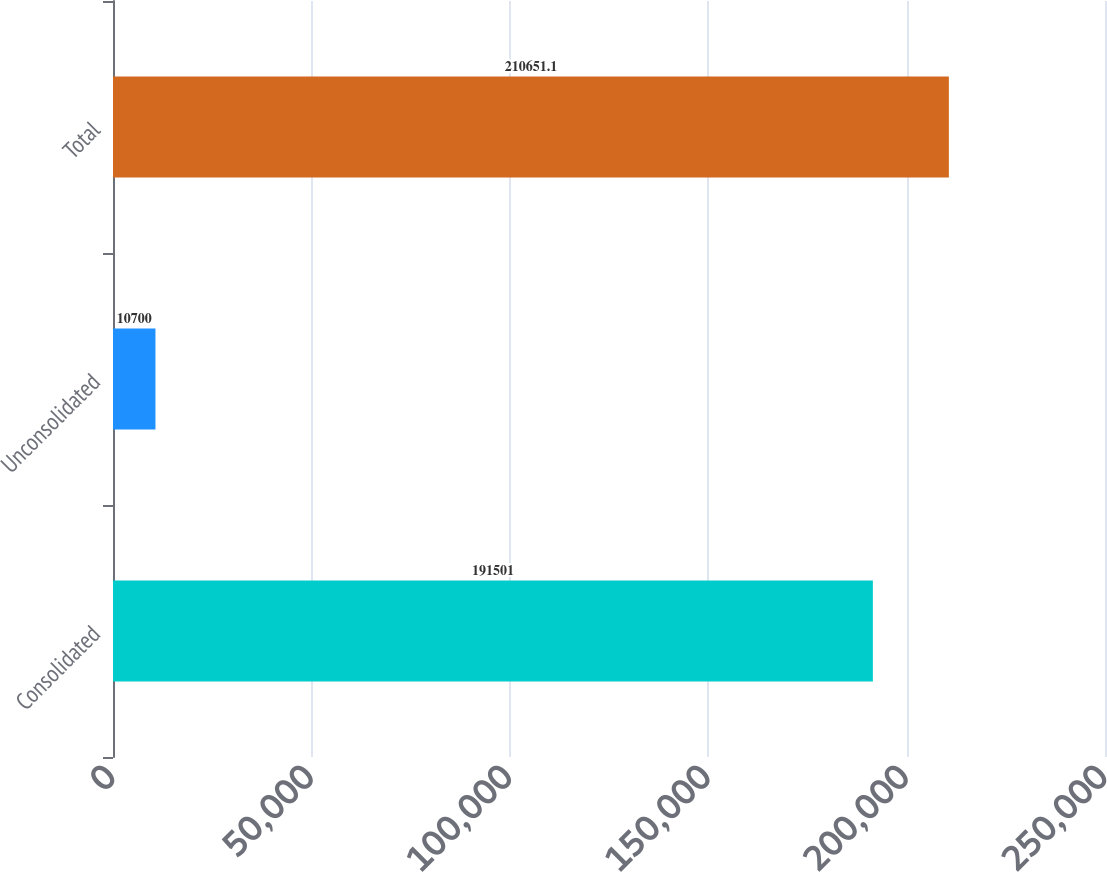Convert chart to OTSL. <chart><loc_0><loc_0><loc_500><loc_500><bar_chart><fcel>Consolidated<fcel>Unconsolidated<fcel>Total<nl><fcel>191501<fcel>10700<fcel>210651<nl></chart> 